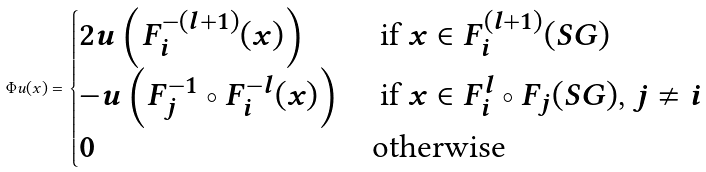<formula> <loc_0><loc_0><loc_500><loc_500>\Phi u ( x ) = \begin{cases} 2 u \left ( F _ { i } ^ { - ( l + 1 ) } ( x ) \right ) & \text { if $x\in F_{i}^{ (l+1)}(SG)$} \\ - u \left ( F _ { j } ^ { - 1 } \circ F _ { i } ^ { - l } ( x ) \right ) & \text { if $x\in F_{i}^{l}\circ F_{j}(SG)$, $j\neq i$} \\ 0 & \text {otherwise} \end{cases}</formula> 